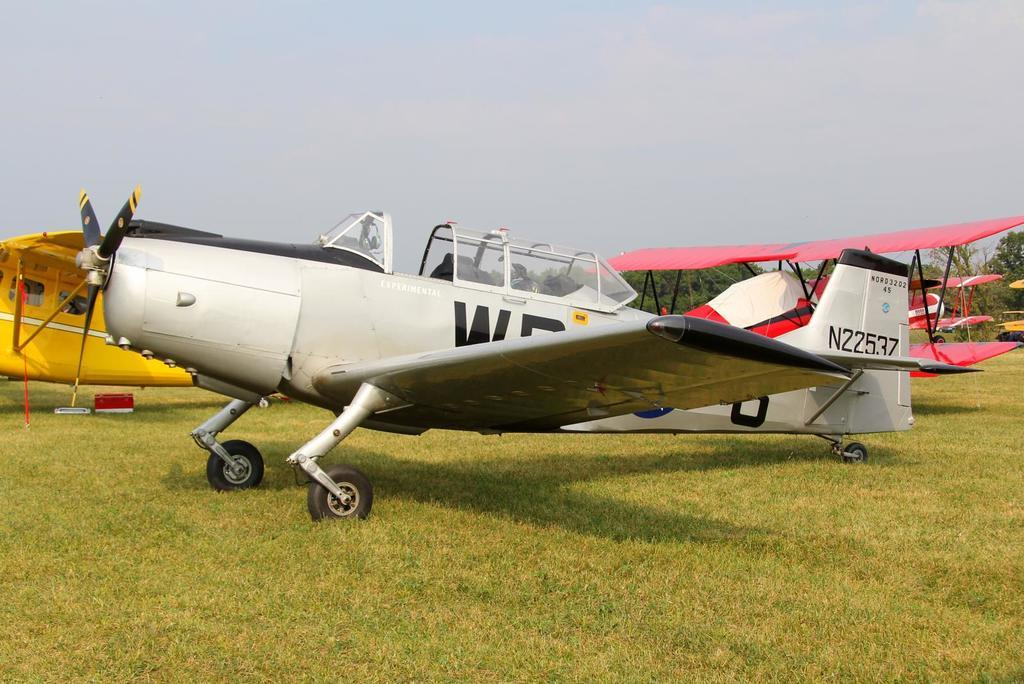<image>
Create a compact narrative representing the image presented. An old gray prop plane has the identifying numbers N22537. 